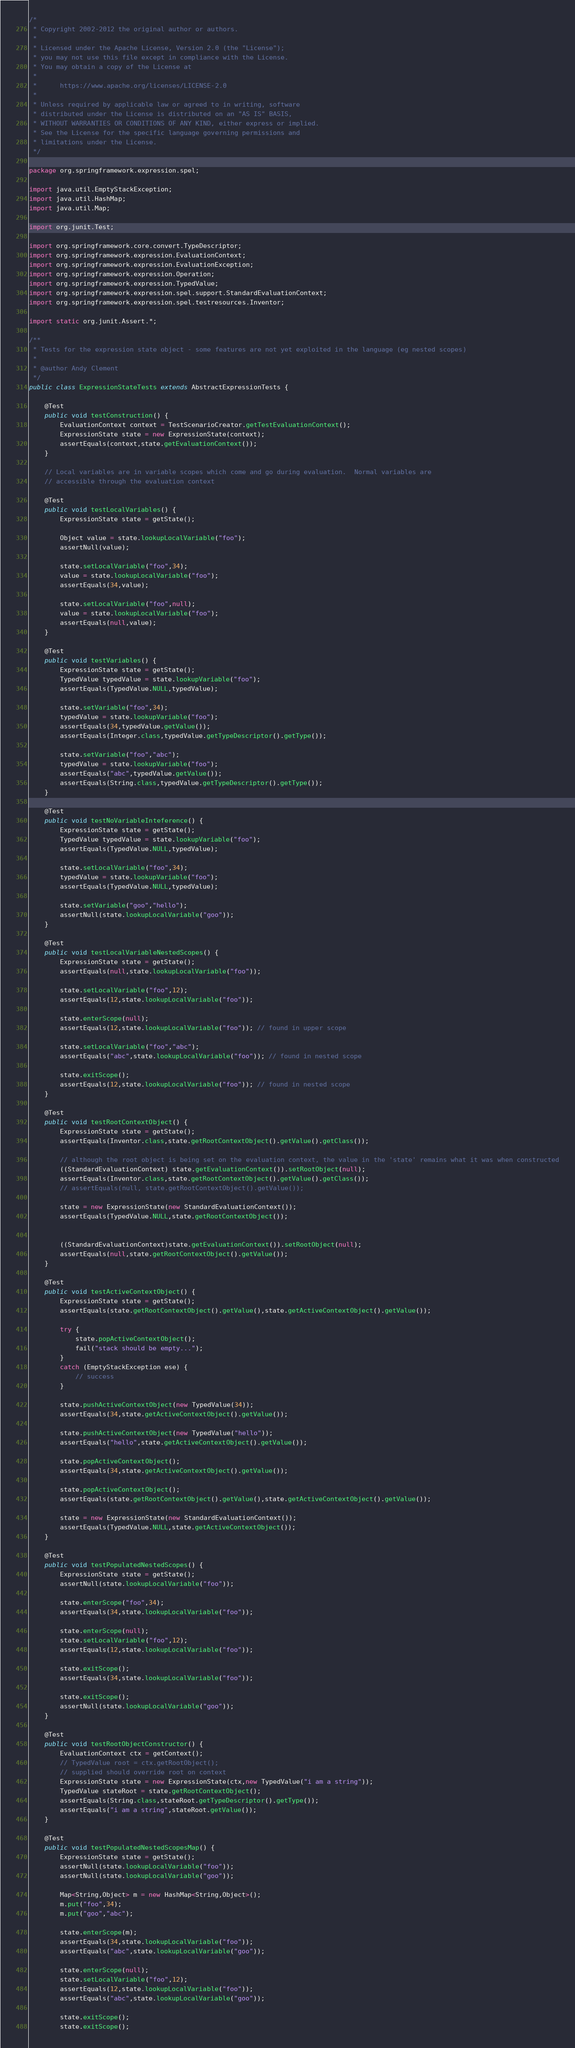<code> <loc_0><loc_0><loc_500><loc_500><_Java_>/*
 * Copyright 2002-2012 the original author or authors.
 *
 * Licensed under the Apache License, Version 2.0 (the "License");
 * you may not use this file except in compliance with the License.
 * You may obtain a copy of the License at
 *
 *      https://www.apache.org/licenses/LICENSE-2.0
 *
 * Unless required by applicable law or agreed to in writing, software
 * distributed under the License is distributed on an "AS IS" BASIS,
 * WITHOUT WARRANTIES OR CONDITIONS OF ANY KIND, either express or implied.
 * See the License for the specific language governing permissions and
 * limitations under the License.
 */

package org.springframework.expression.spel;

import java.util.EmptyStackException;
import java.util.HashMap;
import java.util.Map;

import org.junit.Test;

import org.springframework.core.convert.TypeDescriptor;
import org.springframework.expression.EvaluationContext;
import org.springframework.expression.EvaluationException;
import org.springframework.expression.Operation;
import org.springframework.expression.TypedValue;
import org.springframework.expression.spel.support.StandardEvaluationContext;
import org.springframework.expression.spel.testresources.Inventor;

import static org.junit.Assert.*;

/**
 * Tests for the expression state object - some features are not yet exploited in the language (eg nested scopes)
 *
 * @author Andy Clement
 */
public class ExpressionStateTests extends AbstractExpressionTests {

	@Test
	public void testConstruction() {
		EvaluationContext context = TestScenarioCreator.getTestEvaluationContext();
		ExpressionState state = new ExpressionState(context);
		assertEquals(context,state.getEvaluationContext());
	}

	// Local variables are in variable scopes which come and go during evaluation.  Normal variables are
	// accessible through the evaluation context

	@Test
	public void testLocalVariables() {
		ExpressionState state = getState();

		Object value = state.lookupLocalVariable("foo");
		assertNull(value);

		state.setLocalVariable("foo",34);
		value = state.lookupLocalVariable("foo");
		assertEquals(34,value);

		state.setLocalVariable("foo",null);
		value = state.lookupLocalVariable("foo");
		assertEquals(null,value);
	}

	@Test
	public void testVariables() {
		ExpressionState state = getState();
		TypedValue typedValue = state.lookupVariable("foo");
		assertEquals(TypedValue.NULL,typedValue);

		state.setVariable("foo",34);
		typedValue = state.lookupVariable("foo");
		assertEquals(34,typedValue.getValue());
		assertEquals(Integer.class,typedValue.getTypeDescriptor().getType());

		state.setVariable("foo","abc");
		typedValue = state.lookupVariable("foo");
		assertEquals("abc",typedValue.getValue());
		assertEquals(String.class,typedValue.getTypeDescriptor().getType());
	}

	@Test
	public void testNoVariableInteference() {
		ExpressionState state = getState();
		TypedValue typedValue = state.lookupVariable("foo");
		assertEquals(TypedValue.NULL,typedValue);

		state.setLocalVariable("foo",34);
		typedValue = state.lookupVariable("foo");
		assertEquals(TypedValue.NULL,typedValue);

		state.setVariable("goo","hello");
		assertNull(state.lookupLocalVariable("goo"));
	}

	@Test
	public void testLocalVariableNestedScopes() {
		ExpressionState state = getState();
		assertEquals(null,state.lookupLocalVariable("foo"));

		state.setLocalVariable("foo",12);
		assertEquals(12,state.lookupLocalVariable("foo"));

		state.enterScope(null);
		assertEquals(12,state.lookupLocalVariable("foo")); // found in upper scope

		state.setLocalVariable("foo","abc");
		assertEquals("abc",state.lookupLocalVariable("foo")); // found in nested scope

		state.exitScope();
		assertEquals(12,state.lookupLocalVariable("foo")); // found in nested scope
	}

	@Test
	public void testRootContextObject() {
		ExpressionState state = getState();
		assertEquals(Inventor.class,state.getRootContextObject().getValue().getClass());

		// although the root object is being set on the evaluation context, the value in the 'state' remains what it was when constructed
		((StandardEvaluationContext) state.getEvaluationContext()).setRootObject(null);
		assertEquals(Inventor.class,state.getRootContextObject().getValue().getClass());
		// assertEquals(null, state.getRootContextObject().getValue());

		state = new ExpressionState(new StandardEvaluationContext());
		assertEquals(TypedValue.NULL,state.getRootContextObject());


		((StandardEvaluationContext)state.getEvaluationContext()).setRootObject(null);
		assertEquals(null,state.getRootContextObject().getValue());
	}

	@Test
	public void testActiveContextObject() {
		ExpressionState state = getState();
		assertEquals(state.getRootContextObject().getValue(),state.getActiveContextObject().getValue());

		try {
			state.popActiveContextObject();
			fail("stack should be empty...");
		}
		catch (EmptyStackException ese) {
			// success
		}

		state.pushActiveContextObject(new TypedValue(34));
		assertEquals(34,state.getActiveContextObject().getValue());

		state.pushActiveContextObject(new TypedValue("hello"));
		assertEquals("hello",state.getActiveContextObject().getValue());

		state.popActiveContextObject();
		assertEquals(34,state.getActiveContextObject().getValue());

		state.popActiveContextObject();
		assertEquals(state.getRootContextObject().getValue(),state.getActiveContextObject().getValue());

		state = new ExpressionState(new StandardEvaluationContext());
		assertEquals(TypedValue.NULL,state.getActiveContextObject());
	}

	@Test
	public void testPopulatedNestedScopes() {
		ExpressionState state = getState();
		assertNull(state.lookupLocalVariable("foo"));

		state.enterScope("foo",34);
		assertEquals(34,state.lookupLocalVariable("foo"));

		state.enterScope(null);
		state.setLocalVariable("foo",12);
		assertEquals(12,state.lookupLocalVariable("foo"));

		state.exitScope();
		assertEquals(34,state.lookupLocalVariable("foo"));

		state.exitScope();
		assertNull(state.lookupLocalVariable("goo"));
	}

	@Test
	public void testRootObjectConstructor() {
		EvaluationContext ctx = getContext();
		// TypedValue root = ctx.getRootObject();
		// supplied should override root on context
		ExpressionState state = new ExpressionState(ctx,new TypedValue("i am a string"));
		TypedValue stateRoot = state.getRootContextObject();
		assertEquals(String.class,stateRoot.getTypeDescriptor().getType());
		assertEquals("i am a string",stateRoot.getValue());
	}

	@Test
	public void testPopulatedNestedScopesMap() {
		ExpressionState state = getState();
		assertNull(state.lookupLocalVariable("foo"));
		assertNull(state.lookupLocalVariable("goo"));

		Map<String,Object> m = new HashMap<String,Object>();
		m.put("foo",34);
		m.put("goo","abc");

		state.enterScope(m);
		assertEquals(34,state.lookupLocalVariable("foo"));
		assertEquals("abc",state.lookupLocalVariable("goo"));

		state.enterScope(null);
		state.setLocalVariable("foo",12);
		assertEquals(12,state.lookupLocalVariable("foo"));
		assertEquals("abc",state.lookupLocalVariable("goo"));

		state.exitScope();
		state.exitScope();</code> 